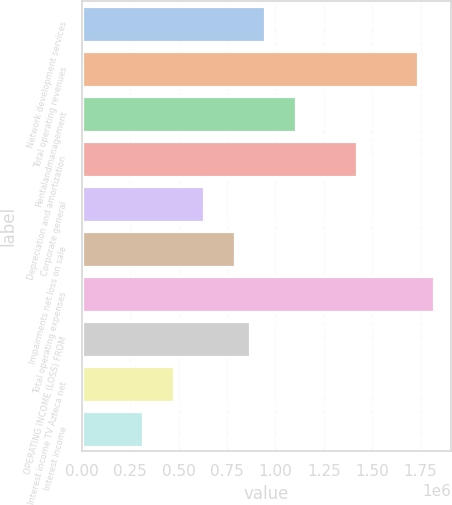Convert chart to OTSL. <chart><loc_0><loc_0><loc_500><loc_500><bar_chart><fcel>Network development services<fcel>Total operating revenues<fcel>Rentalandmanagement<fcel>Depreciation and amortization<fcel>Corporate general<fcel>Impairments net loss on sale<fcel>Total operating expenses<fcel>OPERATING INCOME (LOSS) FROM<fcel>Interest income TV Azteca net<fcel>Interest income<nl><fcel>947813<fcel>1.73766e+06<fcel>1.10578e+06<fcel>1.42172e+06<fcel>631875<fcel>789844<fcel>1.81664e+06<fcel>868828<fcel>473907<fcel>315938<nl></chart> 